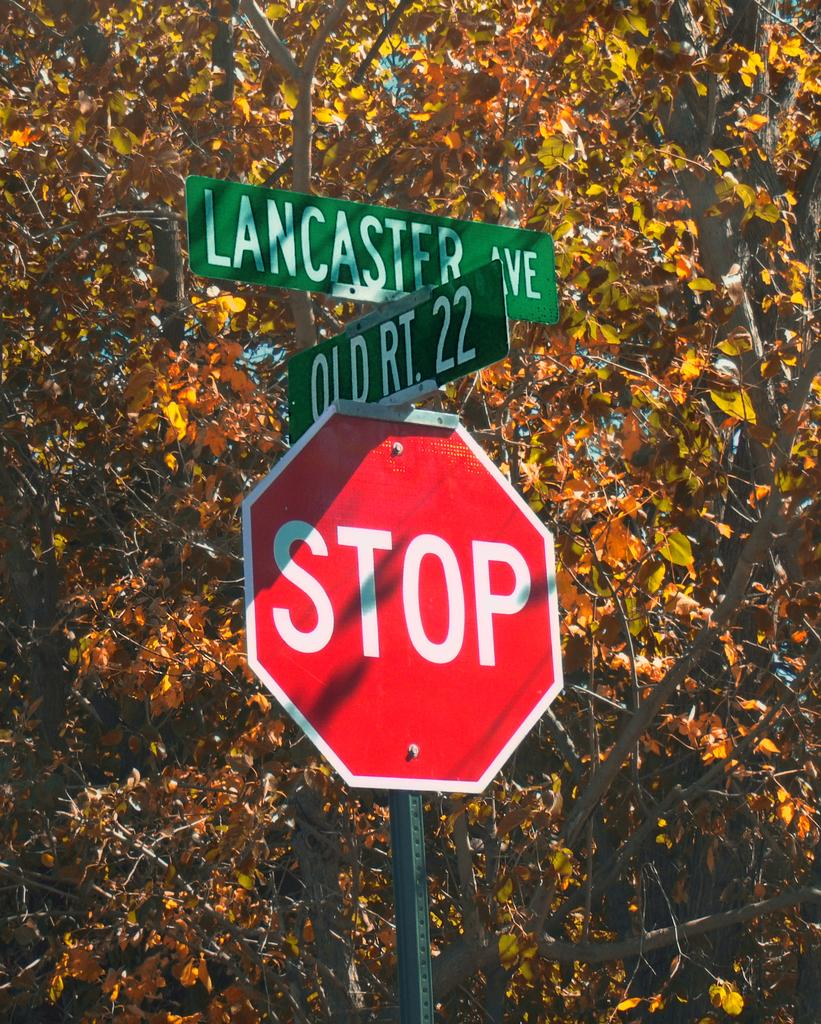<image>
Present a compact description of the photo's key features. A STOP sign below street signs for Lancaster ave and Old Rt. 22. 